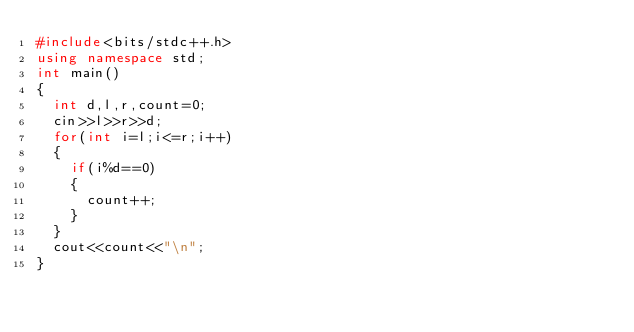Convert code to text. <code><loc_0><loc_0><loc_500><loc_500><_C++_>#include<bits/stdc++.h>
using namespace std;
int main()
{
  int d,l,r,count=0;
  cin>>l>>r>>d;
  for(int i=l;i<=r;i++)
  {
    if(i%d==0)
    {
      count++;
    }
  }
  cout<<count<<"\n";
}
</code> 